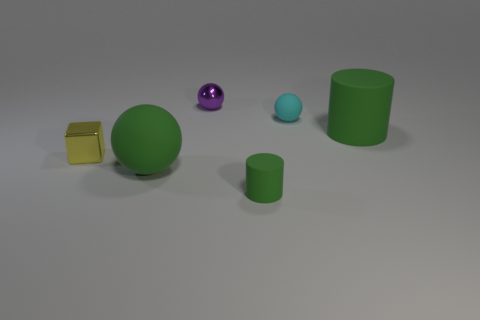Subtract 1 spheres. How many spheres are left? 2 Add 1 green cylinders. How many objects exist? 7 Subtract all blocks. How many objects are left? 5 Add 1 small yellow metallic things. How many small yellow metallic things are left? 2 Add 2 big green balls. How many big green balls exist? 3 Subtract 0 cyan blocks. How many objects are left? 6 Subtract all green matte things. Subtract all small brown metallic objects. How many objects are left? 3 